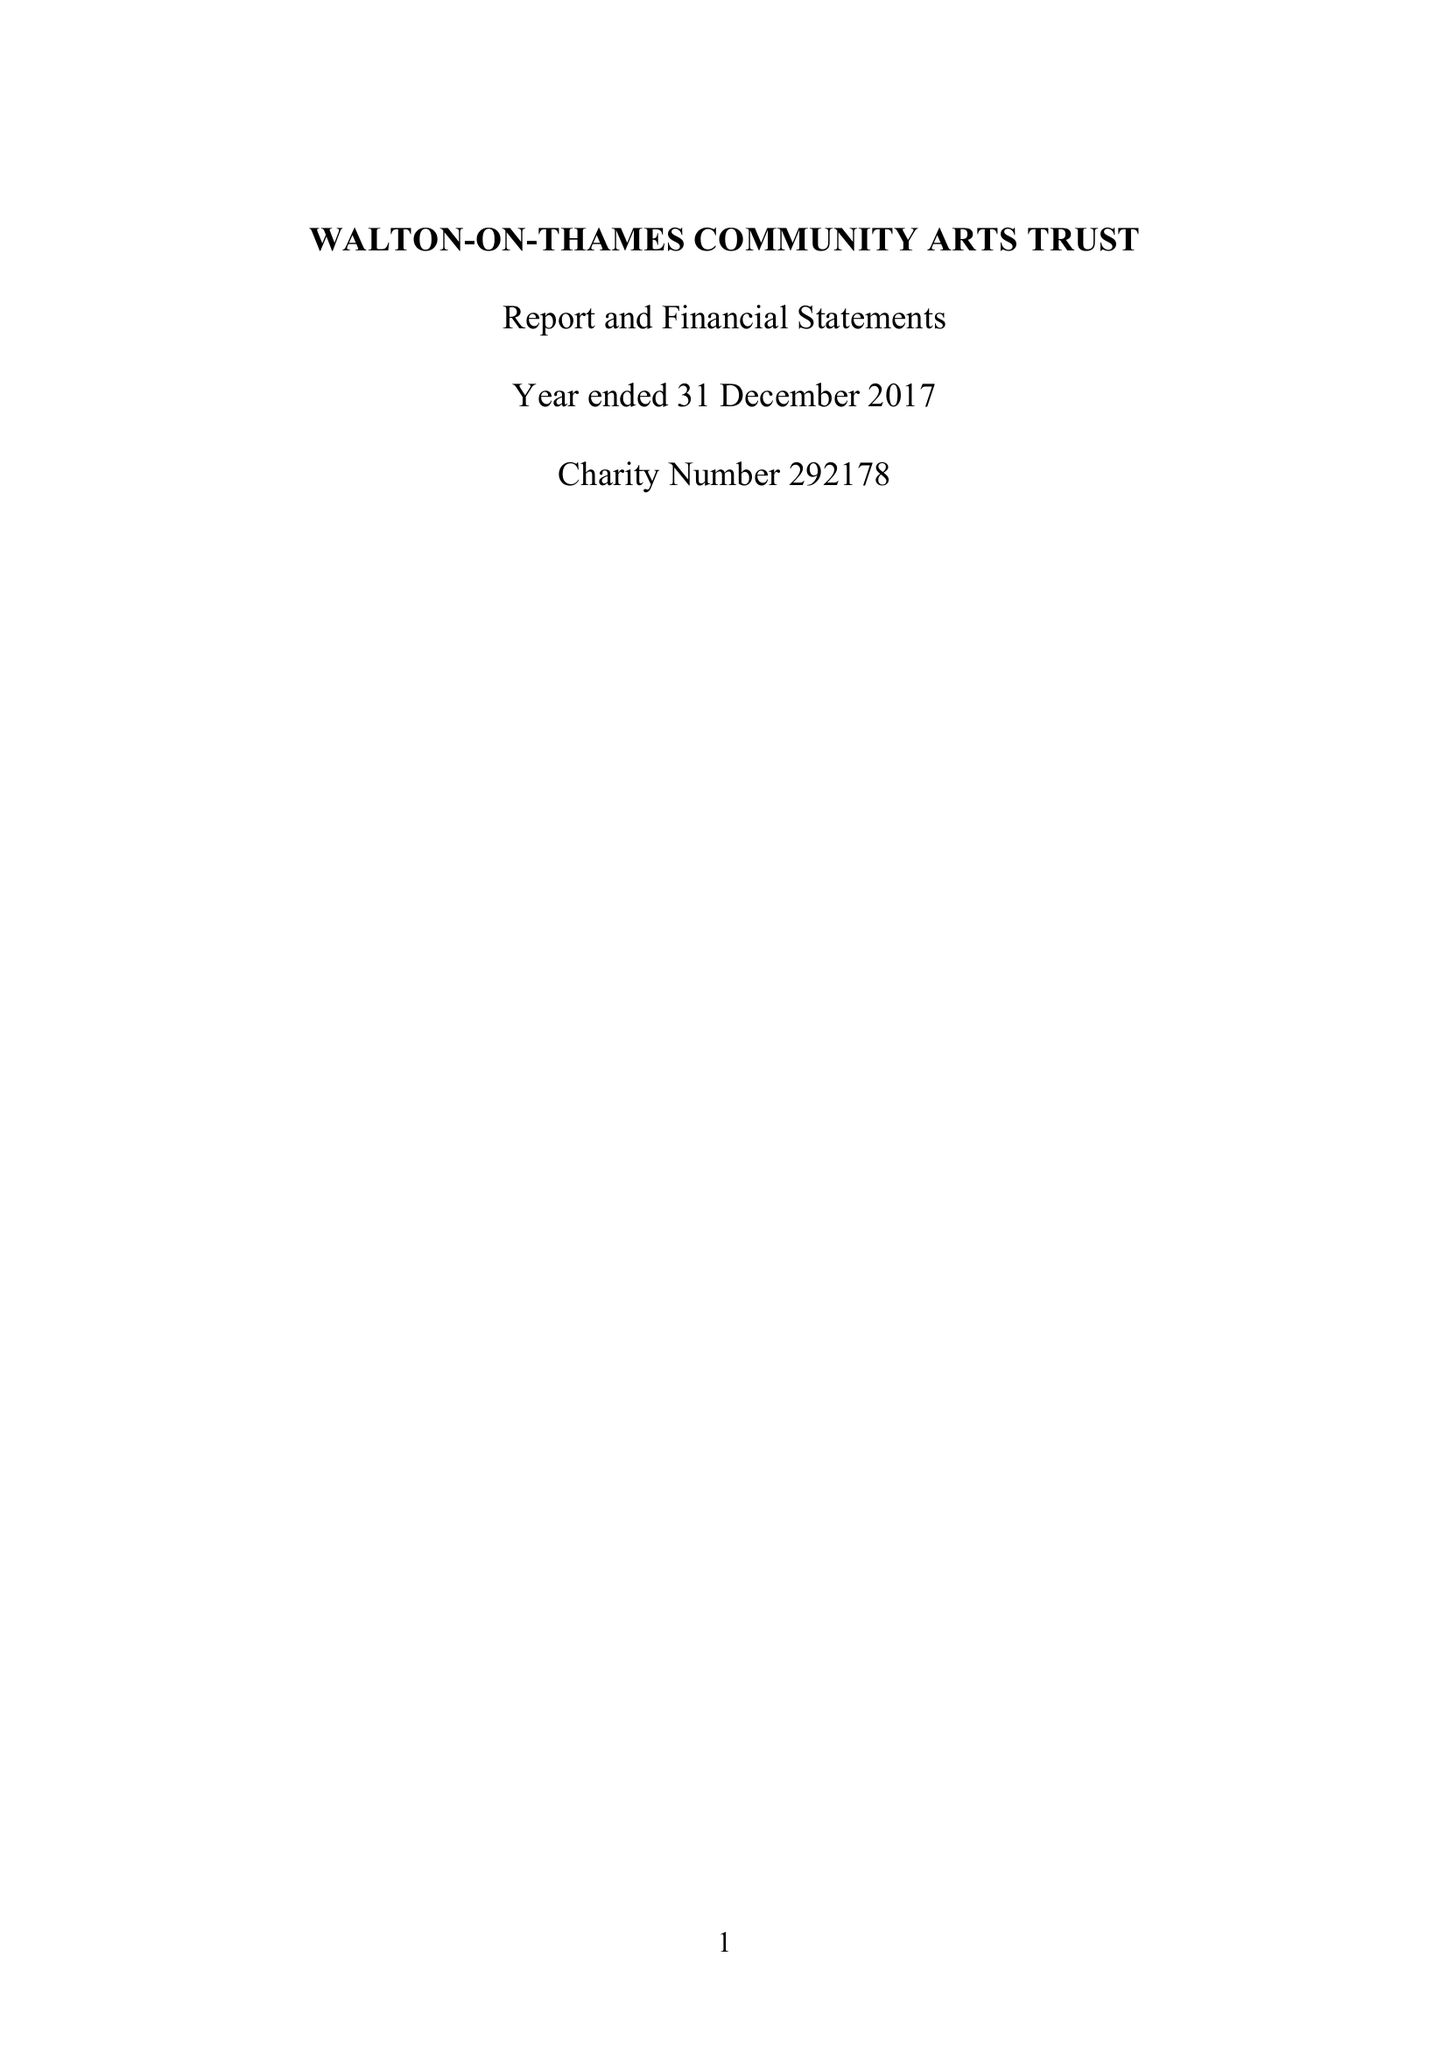What is the value for the charity_number?
Answer the question using a single word or phrase. 292178 